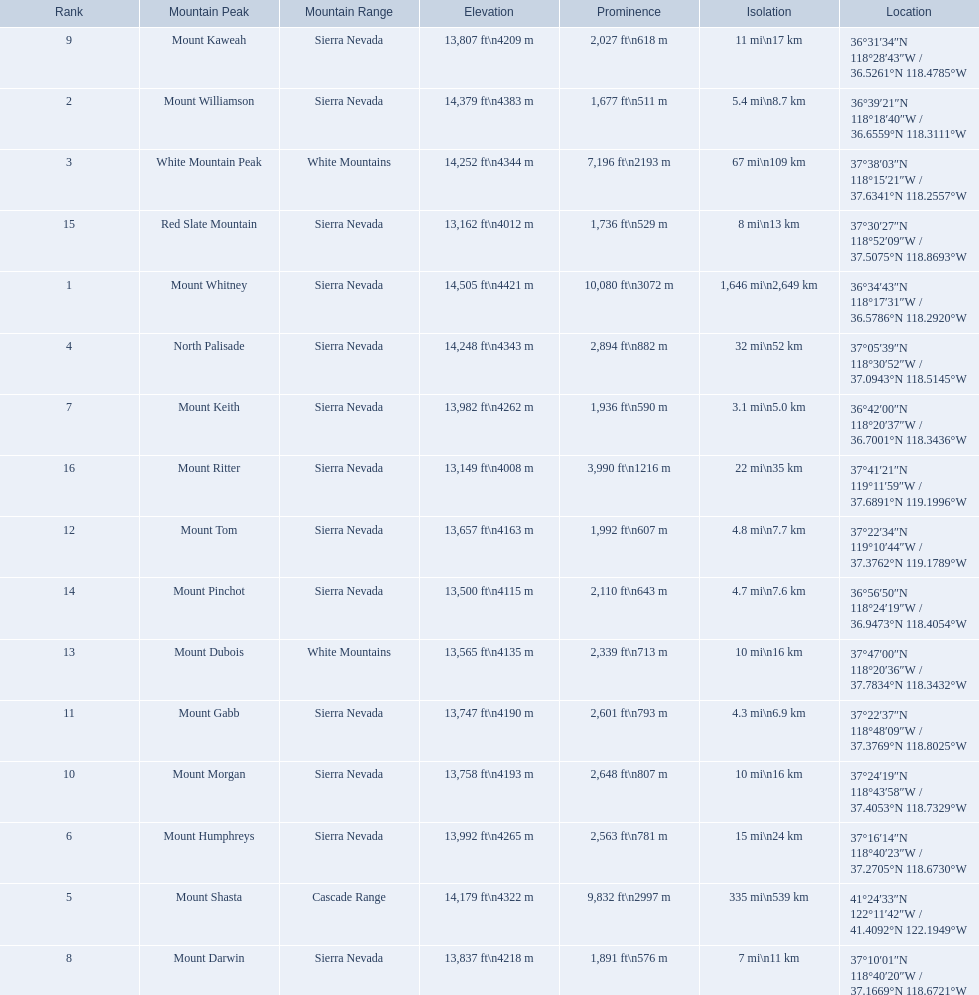Which are the highest mountain peaks in california? Mount Whitney, Mount Williamson, White Mountain Peak, North Palisade, Mount Shasta, Mount Humphreys, Mount Keith, Mount Darwin, Mount Kaweah, Mount Morgan, Mount Gabb, Mount Tom, Mount Dubois, Mount Pinchot, Red Slate Mountain, Mount Ritter. Of those, which are not in the sierra nevada range? White Mountain Peak, Mount Shasta, Mount Dubois. Of the mountains not in the sierra nevada range, which is the only mountain in the cascades? Mount Shasta. 